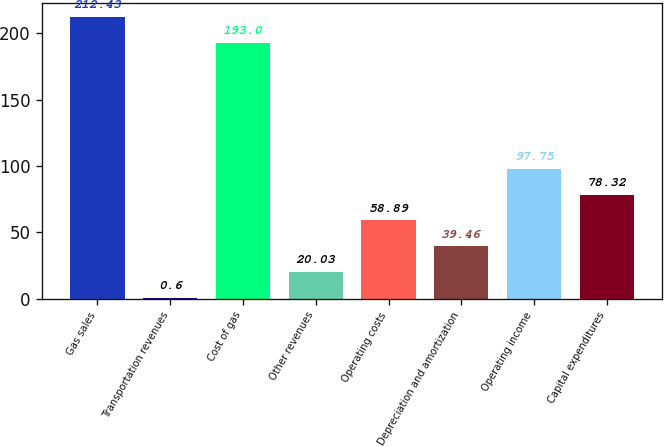Convert chart to OTSL. <chart><loc_0><loc_0><loc_500><loc_500><bar_chart><fcel>Gas sales<fcel>Transportation revenues<fcel>Cost of gas<fcel>Other revenues<fcel>Operating costs<fcel>Depreciation and amortization<fcel>Operating income<fcel>Capital expenditures<nl><fcel>212.43<fcel>0.6<fcel>193<fcel>20.03<fcel>58.89<fcel>39.46<fcel>97.75<fcel>78.32<nl></chart> 